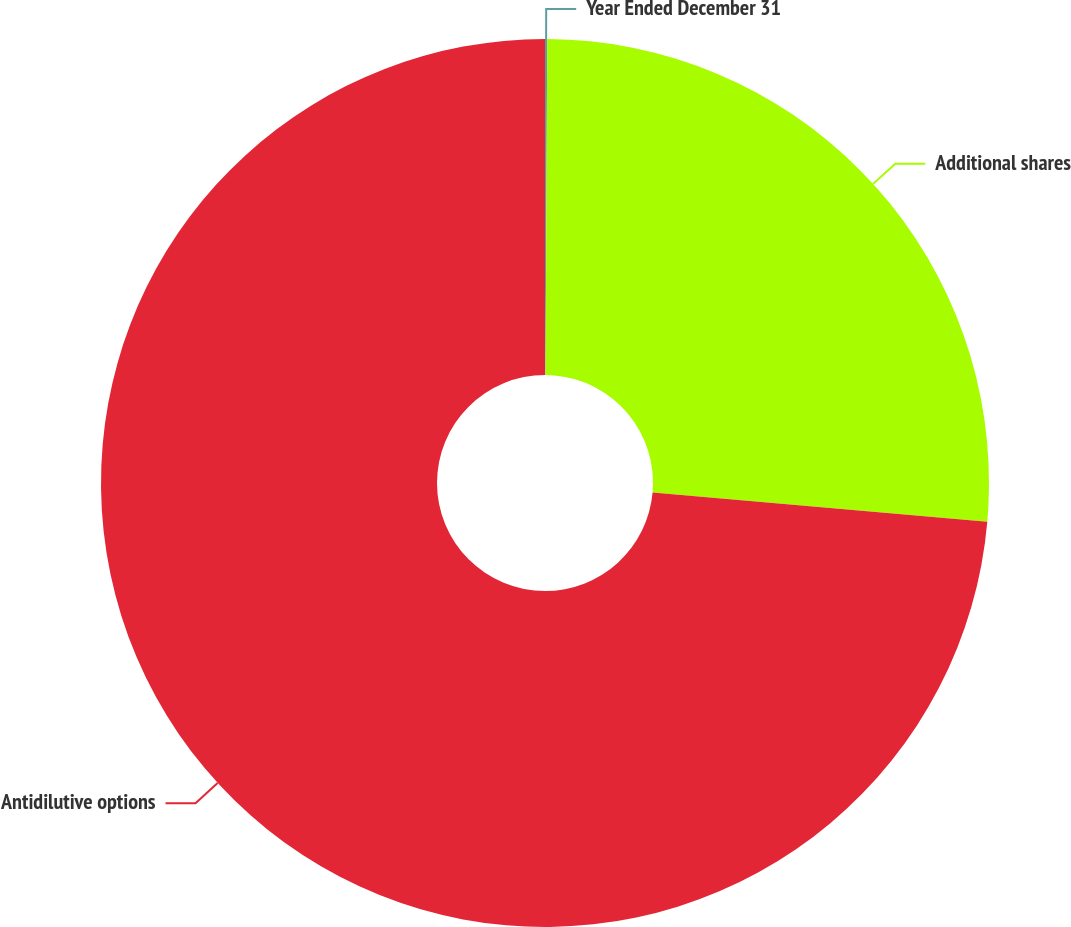Convert chart. <chart><loc_0><loc_0><loc_500><loc_500><pie_chart><fcel>Year Ended December 31<fcel>Additional shares<fcel>Antidilutive options<nl><fcel>0.08%<fcel>26.31%<fcel>73.61%<nl></chart> 